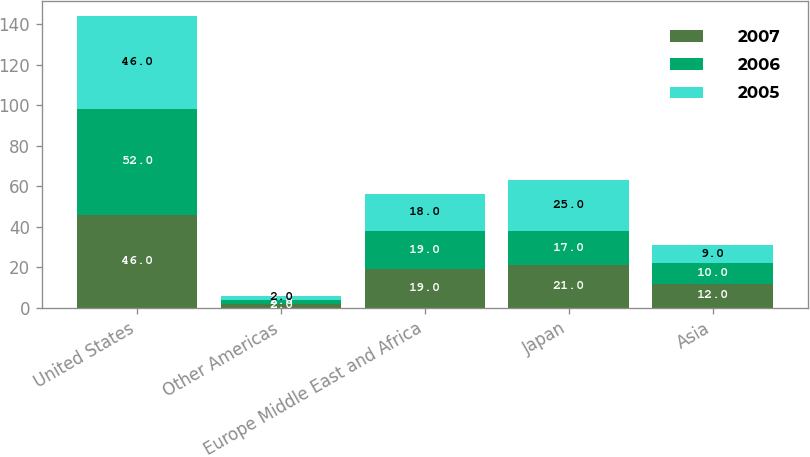Convert chart to OTSL. <chart><loc_0><loc_0><loc_500><loc_500><stacked_bar_chart><ecel><fcel>United States<fcel>Other Americas<fcel>Europe Middle East and Africa<fcel>Japan<fcel>Asia<nl><fcel>2007<fcel>46<fcel>2<fcel>19<fcel>21<fcel>12<nl><fcel>2006<fcel>52<fcel>2<fcel>19<fcel>17<fcel>10<nl><fcel>2005<fcel>46<fcel>2<fcel>18<fcel>25<fcel>9<nl></chart> 